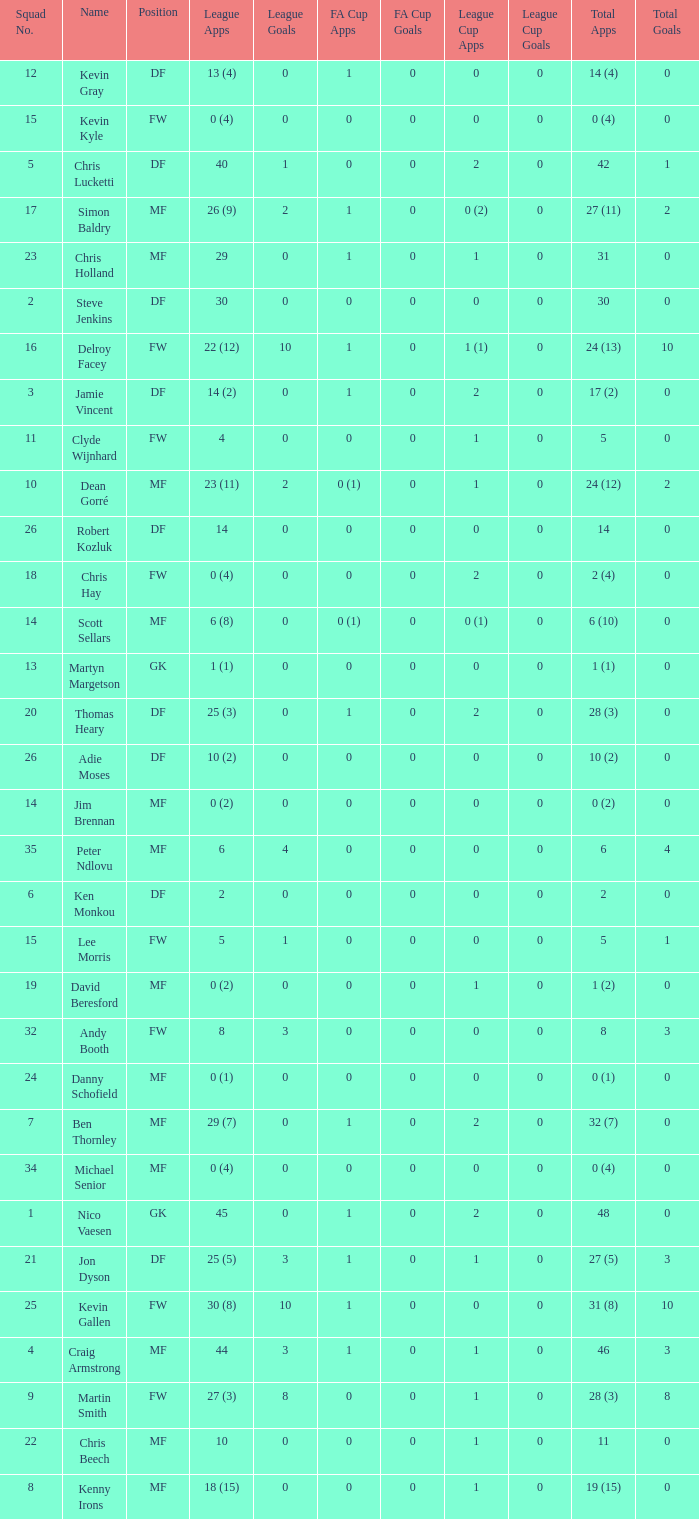Can you tell me the sum of FA Cup Goals that has the League Cup Goals larger than 0? None. 